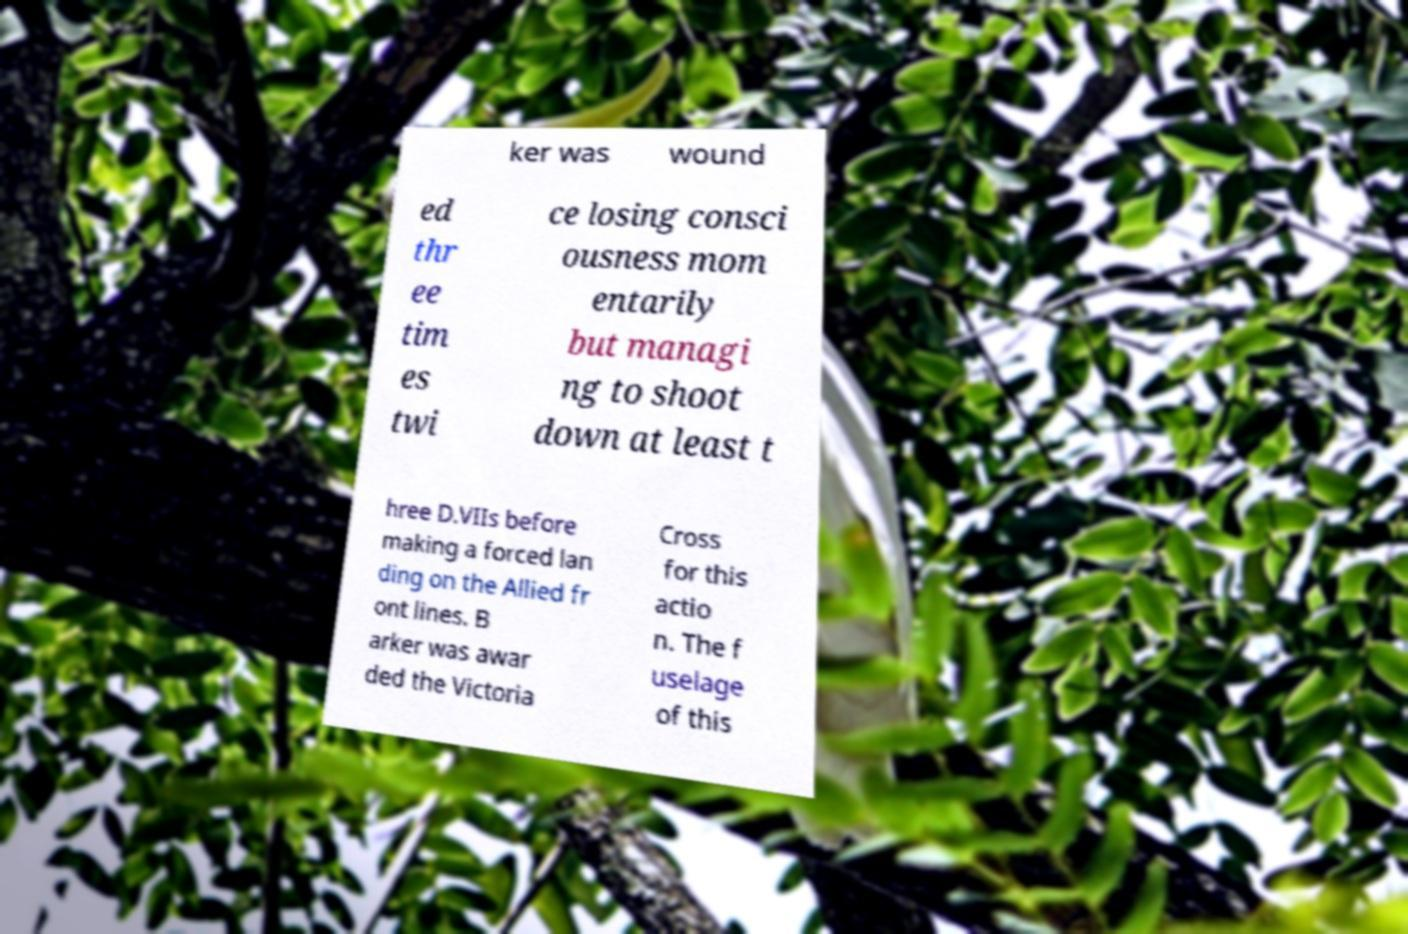What messages or text are displayed in this image? I need them in a readable, typed format. ker was wound ed thr ee tim es twi ce losing consci ousness mom entarily but managi ng to shoot down at least t hree D.VIIs before making a forced lan ding on the Allied fr ont lines. B arker was awar ded the Victoria Cross for this actio n. The f uselage of this 